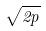Convert formula to latex. <formula><loc_0><loc_0><loc_500><loc_500>\sqrt { 2 p }</formula> 